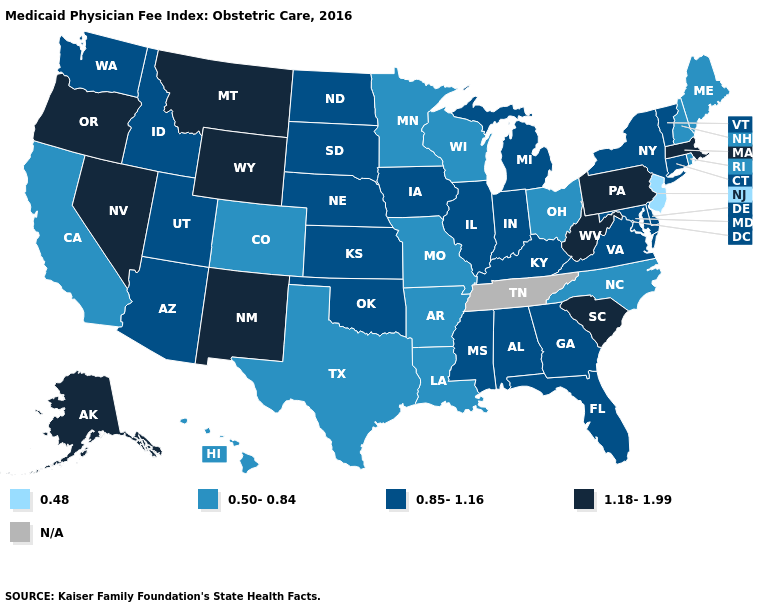What is the value of Illinois?
Quick response, please. 0.85-1.16. What is the value of Hawaii?
Write a very short answer. 0.50-0.84. What is the value of Montana?
Be succinct. 1.18-1.99. Name the states that have a value in the range N/A?
Concise answer only. Tennessee. Does Montana have the highest value in the West?
Give a very brief answer. Yes. What is the lowest value in the South?
Short answer required. 0.50-0.84. Among the states that border Ohio , which have the lowest value?
Answer briefly. Indiana, Kentucky, Michigan. How many symbols are there in the legend?
Be succinct. 5. Name the states that have a value in the range N/A?
Give a very brief answer. Tennessee. What is the highest value in states that border Texas?
Answer briefly. 1.18-1.99. What is the value of Oregon?
Give a very brief answer. 1.18-1.99. What is the lowest value in the USA?
Short answer required. 0.48. Among the states that border Wyoming , which have the highest value?
Be succinct. Montana. Does Arkansas have the lowest value in the South?
Give a very brief answer. Yes. Name the states that have a value in the range 0.50-0.84?
Answer briefly. Arkansas, California, Colorado, Hawaii, Louisiana, Maine, Minnesota, Missouri, New Hampshire, North Carolina, Ohio, Rhode Island, Texas, Wisconsin. 